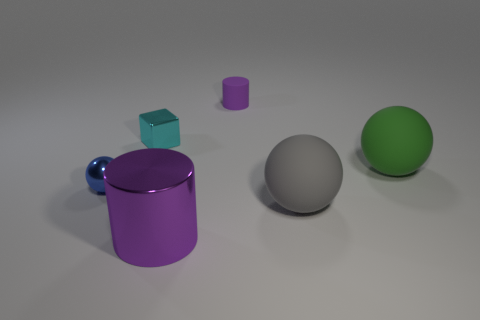Subtract all matte balls. How many balls are left? 1 Add 2 small purple matte objects. How many objects exist? 8 Subtract all cylinders. How many objects are left? 4 Add 2 shiny blocks. How many shiny blocks are left? 3 Add 5 gray matte spheres. How many gray matte spheres exist? 6 Subtract all green balls. How many balls are left? 2 Subtract 0 brown spheres. How many objects are left? 6 Subtract all yellow cylinders. Subtract all cyan spheres. How many cylinders are left? 2 Subtract all blue blocks. How many blue cylinders are left? 0 Subtract all large gray matte things. Subtract all matte spheres. How many objects are left? 3 